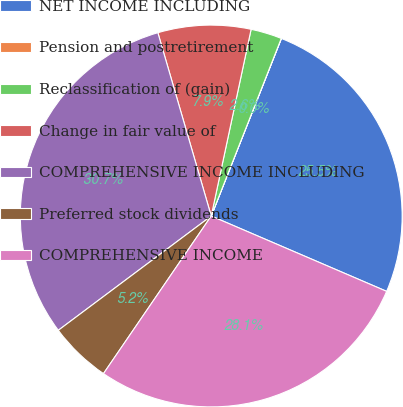<chart> <loc_0><loc_0><loc_500><loc_500><pie_chart><fcel>NET INCOME INCLUDING<fcel>Pension and postretirement<fcel>Reclassification of (gain)<fcel>Change in fair value of<fcel>COMPREHENSIVE INCOME INCLUDING<fcel>Preferred stock dividends<fcel>COMPREHENSIVE INCOME<nl><fcel>25.47%<fcel>0.01%<fcel>2.63%<fcel>7.86%<fcel>30.71%<fcel>5.24%<fcel>28.09%<nl></chart> 